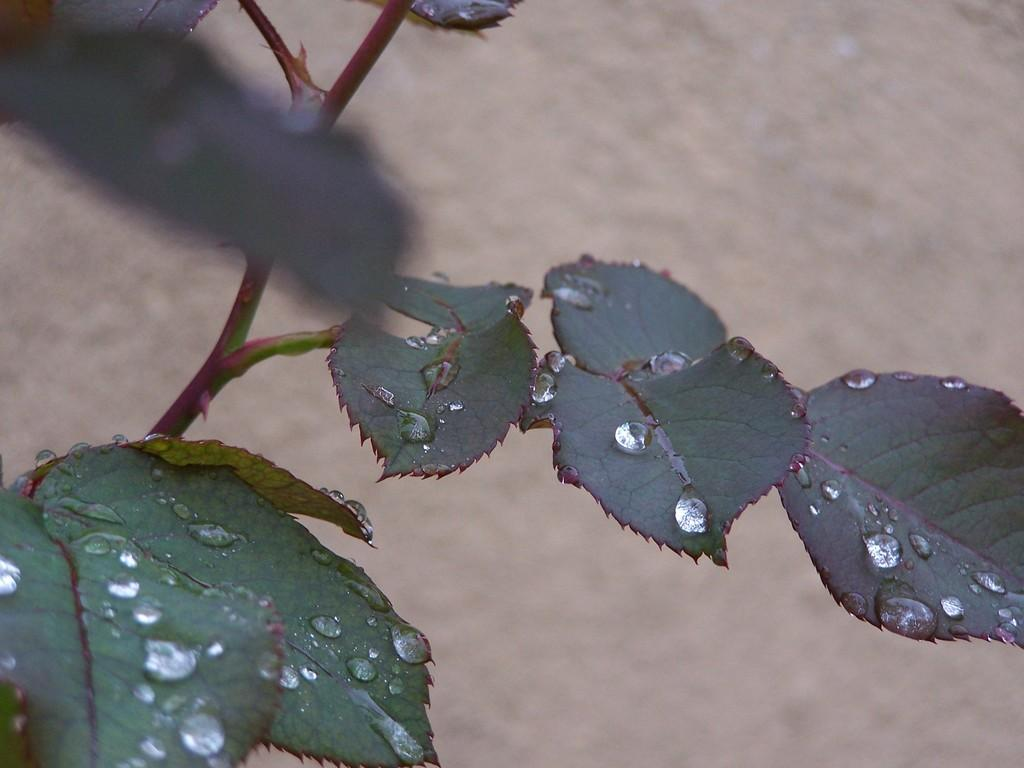What is the main subject of the image? There is a plant in the image. Can you describe the background of the image? The background of the image is blurred. What degree of difficulty is the net shown in the image? There is no net present in the image, so it is not possible to determine the degree of difficulty. 